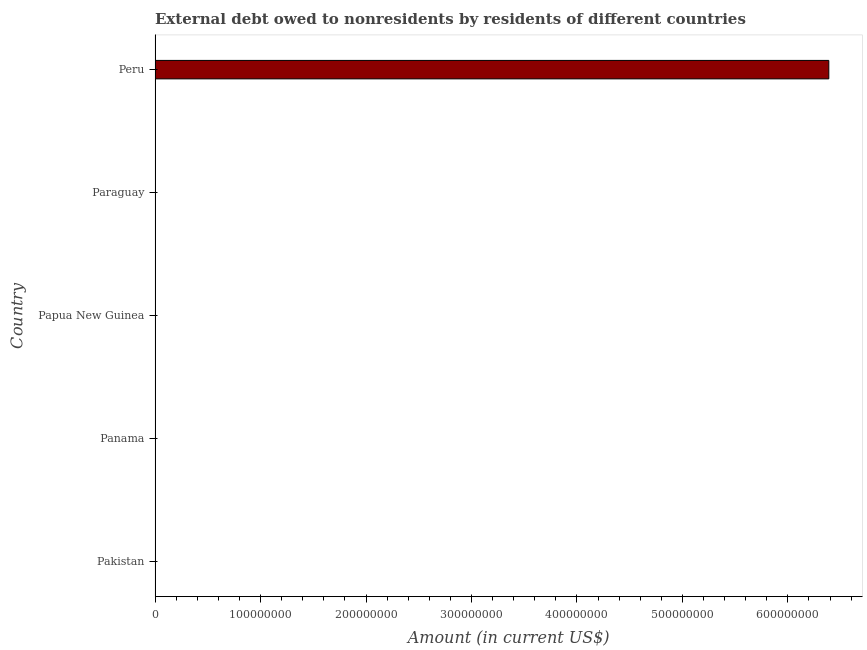Does the graph contain grids?
Your answer should be compact. No. What is the title of the graph?
Keep it short and to the point. External debt owed to nonresidents by residents of different countries. What is the label or title of the X-axis?
Offer a terse response. Amount (in current US$). What is the label or title of the Y-axis?
Keep it short and to the point. Country. What is the debt in Peru?
Your response must be concise. 6.39e+08. Across all countries, what is the maximum debt?
Keep it short and to the point. 6.39e+08. In which country was the debt maximum?
Your answer should be very brief. Peru. What is the sum of the debt?
Keep it short and to the point. 6.39e+08. What is the average debt per country?
Offer a terse response. 1.28e+08. What is the median debt?
Your response must be concise. 0. In how many countries, is the debt greater than 500000000 US$?
Offer a terse response. 1. What is the difference between the highest and the lowest debt?
Provide a succinct answer. 6.39e+08. How many bars are there?
Your answer should be compact. 1. How many countries are there in the graph?
Ensure brevity in your answer.  5. What is the Amount (in current US$) in Papua New Guinea?
Ensure brevity in your answer.  0. What is the Amount (in current US$) in Paraguay?
Provide a short and direct response. 0. What is the Amount (in current US$) of Peru?
Give a very brief answer. 6.39e+08. 